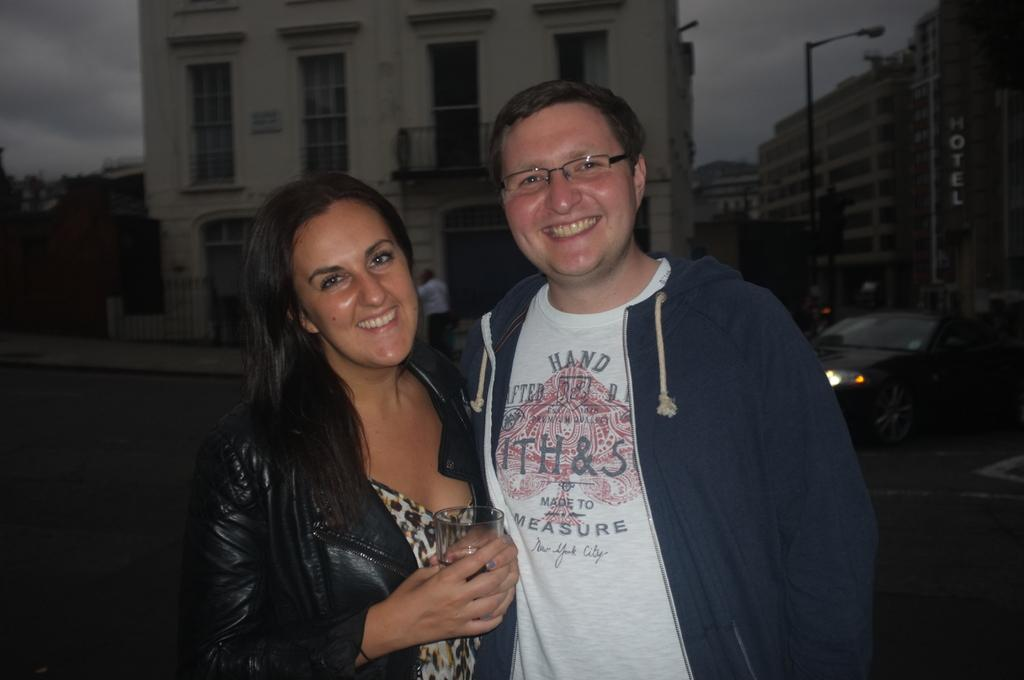What is the setting of the image? The image has an outside view. How many people are in the image? There are two persons in the image. What are the persons wearing? The persons are wearing clothes. Where are the persons standing in relation to the building? The persons are standing in front of a building. What can be seen on the right side of the image? There is a car and a building on the right side of the image. Is there any sign of anger in the image? There is no indication of anger in the image. Is there a fire in the image? There is no fire present in the image. 